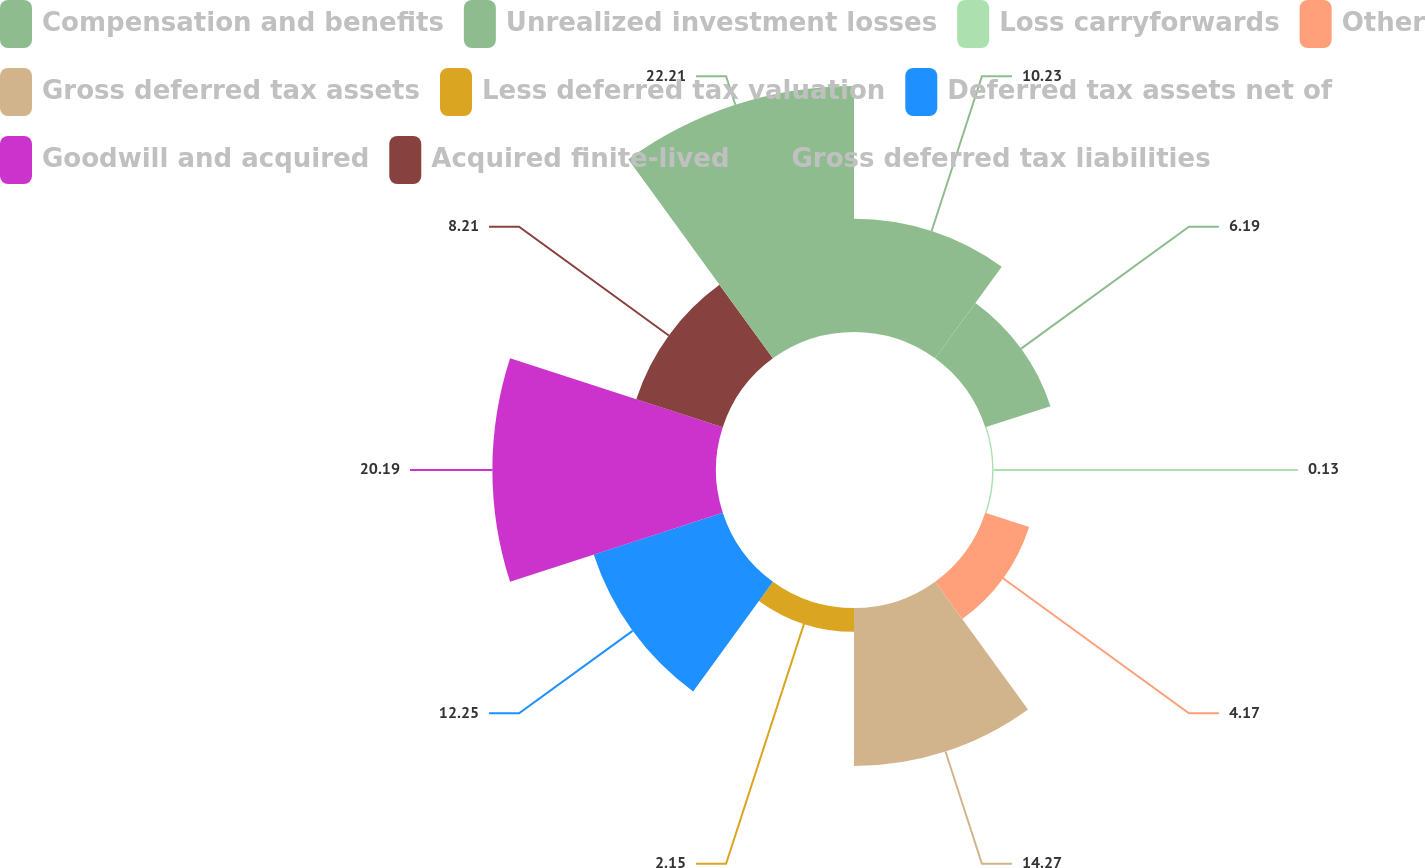Convert chart. <chart><loc_0><loc_0><loc_500><loc_500><pie_chart><fcel>Compensation and benefits<fcel>Unrealized investment losses<fcel>Loss carryforwards<fcel>Other<fcel>Gross deferred tax assets<fcel>Less deferred tax valuation<fcel>Deferred tax assets net of<fcel>Goodwill and acquired<fcel>Acquired finite-lived<fcel>Gross deferred tax liabilities<nl><fcel>10.23%<fcel>6.19%<fcel>0.13%<fcel>4.17%<fcel>14.27%<fcel>2.15%<fcel>12.25%<fcel>20.19%<fcel>8.21%<fcel>22.21%<nl></chart> 